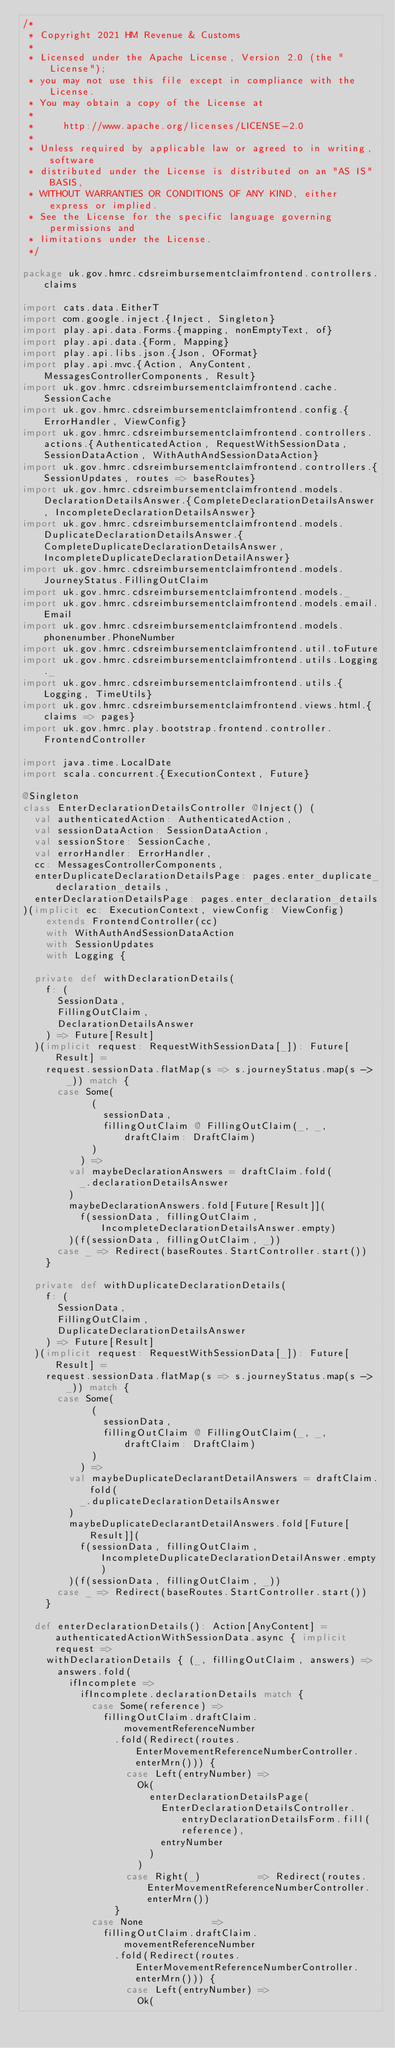<code> <loc_0><loc_0><loc_500><loc_500><_Scala_>/*
 * Copyright 2021 HM Revenue & Customs
 *
 * Licensed under the Apache License, Version 2.0 (the "License");
 * you may not use this file except in compliance with the License.
 * You may obtain a copy of the License at
 *
 *     http://www.apache.org/licenses/LICENSE-2.0
 *
 * Unless required by applicable law or agreed to in writing, software
 * distributed under the License is distributed on an "AS IS" BASIS,
 * WITHOUT WARRANTIES OR CONDITIONS OF ANY KIND, either express or implied.
 * See the License for the specific language governing permissions and
 * limitations under the License.
 */

package uk.gov.hmrc.cdsreimbursementclaimfrontend.controllers.claims

import cats.data.EitherT
import com.google.inject.{Inject, Singleton}
import play.api.data.Forms.{mapping, nonEmptyText, of}
import play.api.data.{Form, Mapping}
import play.api.libs.json.{Json, OFormat}
import play.api.mvc.{Action, AnyContent, MessagesControllerComponents, Result}
import uk.gov.hmrc.cdsreimbursementclaimfrontend.cache.SessionCache
import uk.gov.hmrc.cdsreimbursementclaimfrontend.config.{ErrorHandler, ViewConfig}
import uk.gov.hmrc.cdsreimbursementclaimfrontend.controllers.actions.{AuthenticatedAction, RequestWithSessionData, SessionDataAction, WithAuthAndSessionDataAction}
import uk.gov.hmrc.cdsreimbursementclaimfrontend.controllers.{SessionUpdates, routes => baseRoutes}
import uk.gov.hmrc.cdsreimbursementclaimfrontend.models.DeclarationDetailsAnswer.{CompleteDeclarationDetailsAnswer, IncompleteDeclarationDetailsAnswer}
import uk.gov.hmrc.cdsreimbursementclaimfrontend.models.DuplicateDeclarationDetailsAnswer.{CompleteDuplicateDeclarationDetailsAnswer, IncompleteDuplicateDeclarationDetailAnswer}
import uk.gov.hmrc.cdsreimbursementclaimfrontend.models.JourneyStatus.FillingOutClaim
import uk.gov.hmrc.cdsreimbursementclaimfrontend.models._
import uk.gov.hmrc.cdsreimbursementclaimfrontend.models.email.Email
import uk.gov.hmrc.cdsreimbursementclaimfrontend.models.phonenumber.PhoneNumber
import uk.gov.hmrc.cdsreimbursementclaimfrontend.util.toFuture
import uk.gov.hmrc.cdsreimbursementclaimfrontend.utils.Logging._
import uk.gov.hmrc.cdsreimbursementclaimfrontend.utils.{Logging, TimeUtils}
import uk.gov.hmrc.cdsreimbursementclaimfrontend.views.html.{claims => pages}
import uk.gov.hmrc.play.bootstrap.frontend.controller.FrontendController

import java.time.LocalDate
import scala.concurrent.{ExecutionContext, Future}

@Singleton
class EnterDeclarationDetailsController @Inject() (
  val authenticatedAction: AuthenticatedAction,
  val sessionDataAction: SessionDataAction,
  val sessionStore: SessionCache,
  val errorHandler: ErrorHandler,
  cc: MessagesControllerComponents,
  enterDuplicateDeclarationDetailsPage: pages.enter_duplicate_declaration_details,
  enterDeclarationDetailsPage: pages.enter_declaration_details
)(implicit ec: ExecutionContext, viewConfig: ViewConfig)
    extends FrontendController(cc)
    with WithAuthAndSessionDataAction
    with SessionUpdates
    with Logging {

  private def withDeclarationDetails(
    f: (
      SessionData,
      FillingOutClaim,
      DeclarationDetailsAnswer
    ) => Future[Result]
  )(implicit request: RequestWithSessionData[_]): Future[Result] =
    request.sessionData.flatMap(s => s.journeyStatus.map(s -> _)) match {
      case Some(
            (
              sessionData,
              fillingOutClaim @ FillingOutClaim(_, _, draftClaim: DraftClaim)
            )
          ) =>
        val maybeDeclarationAnswers = draftClaim.fold(
          _.declarationDetailsAnswer
        )
        maybeDeclarationAnswers.fold[Future[Result]](
          f(sessionData, fillingOutClaim, IncompleteDeclarationDetailsAnswer.empty)
        )(f(sessionData, fillingOutClaim, _))
      case _ => Redirect(baseRoutes.StartController.start())
    }

  private def withDuplicateDeclarationDetails(
    f: (
      SessionData,
      FillingOutClaim,
      DuplicateDeclarationDetailsAnswer
    ) => Future[Result]
  )(implicit request: RequestWithSessionData[_]): Future[Result] =
    request.sessionData.flatMap(s => s.journeyStatus.map(s -> _)) match {
      case Some(
            (
              sessionData,
              fillingOutClaim @ FillingOutClaim(_, _, draftClaim: DraftClaim)
            )
          ) =>
        val maybeDuplicateDeclarantDetailAnswers = draftClaim.fold(
          _.duplicateDeclarationDetailsAnswer
        )
        maybeDuplicateDeclarantDetailAnswers.fold[Future[Result]](
          f(sessionData, fillingOutClaim, IncompleteDuplicateDeclarationDetailAnswer.empty)
        )(f(sessionData, fillingOutClaim, _))
      case _ => Redirect(baseRoutes.StartController.start())
    }

  def enterDeclarationDetails(): Action[AnyContent] = authenticatedActionWithSessionData.async { implicit request =>
    withDeclarationDetails { (_, fillingOutClaim, answers) =>
      answers.fold(
        ifIncomplete =>
          ifIncomplete.declarationDetails match {
            case Some(reference) =>
              fillingOutClaim.draftClaim.movementReferenceNumber
                .fold(Redirect(routes.EnterMovementReferenceNumberController.enterMrn())) {
                  case Left(entryNumber) =>
                    Ok(
                      enterDeclarationDetailsPage(
                        EnterDeclarationDetailsController.entryDeclarationDetailsForm.fill(reference),
                        entryNumber
                      )
                    )
                  case Right(_)          => Redirect(routes.EnterMovementReferenceNumberController.enterMrn())
                }
            case None            =>
              fillingOutClaim.draftClaim.movementReferenceNumber
                .fold(Redirect(routes.EnterMovementReferenceNumberController.enterMrn())) {
                  case Left(entryNumber) =>
                    Ok(</code> 